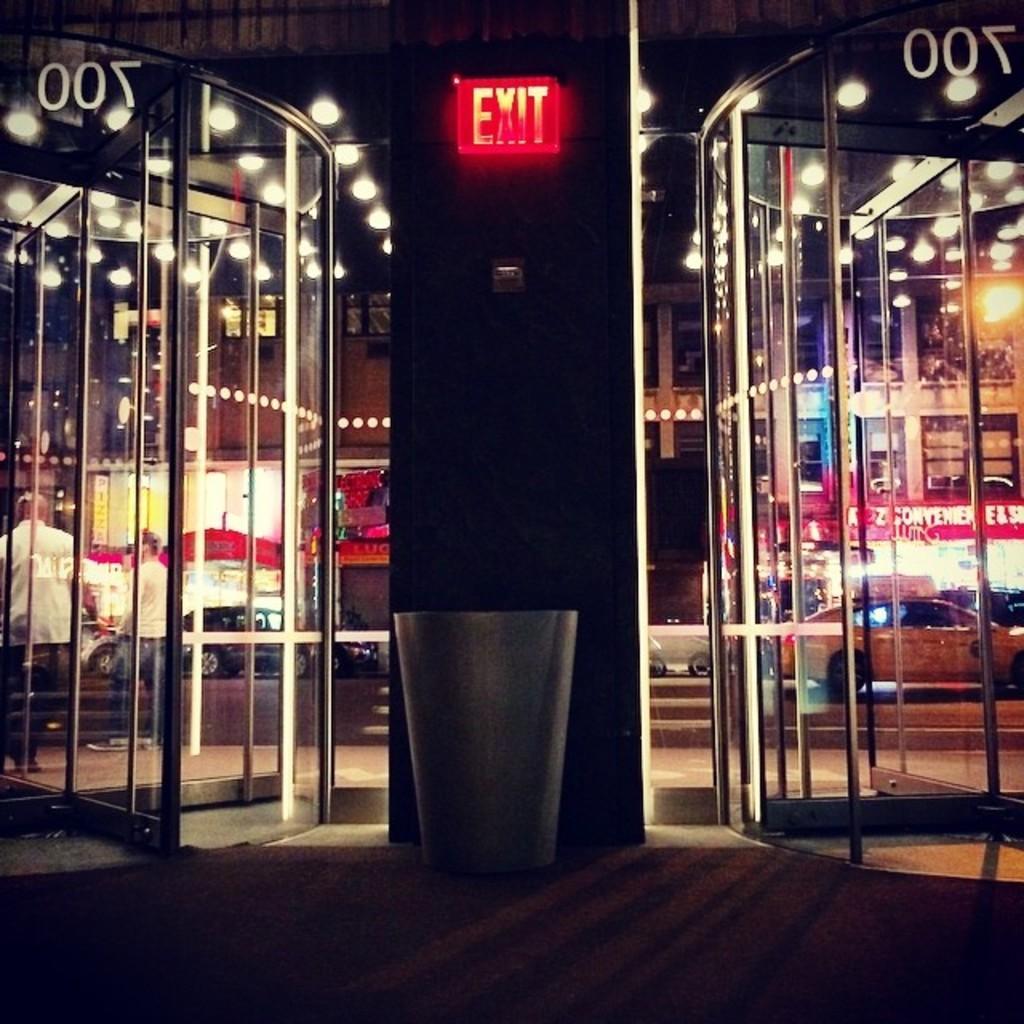How would you summarize this image in a sentence or two? In the center of the image we can see the exit board attached to the pillar. We can also see the bin on the path. On both sides of the image we can see the revolving glass doors and through the glass doors we can see the buildings, lights, people and also the vehicles passing on the road and this image is taken during the night time. 